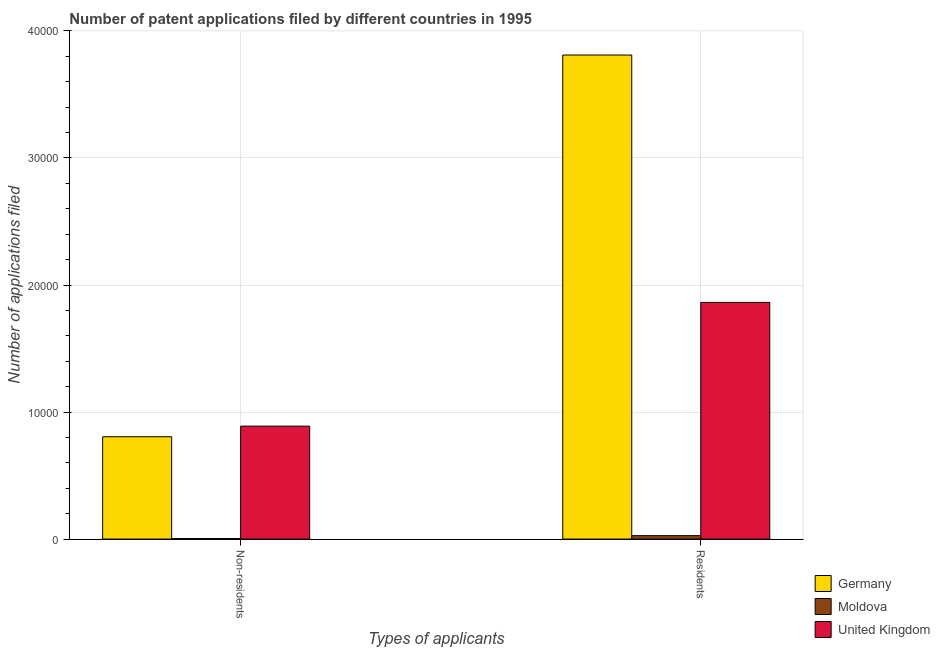How many groups of bars are there?
Provide a short and direct response. 2. Are the number of bars per tick equal to the number of legend labels?
Your answer should be very brief. Yes. Are the number of bars on each tick of the X-axis equal?
Give a very brief answer. Yes. How many bars are there on the 1st tick from the left?
Keep it short and to the point. 3. What is the label of the 2nd group of bars from the left?
Offer a very short reply. Residents. What is the number of patent applications by non residents in United Kingdom?
Make the answer very short. 8891. Across all countries, what is the maximum number of patent applications by residents?
Ensure brevity in your answer.  3.81e+04. Across all countries, what is the minimum number of patent applications by residents?
Keep it short and to the point. 270. In which country was the number of patent applications by residents minimum?
Your answer should be compact. Moldova. What is the total number of patent applications by non residents in the graph?
Make the answer very short. 1.70e+04. What is the difference between the number of patent applications by residents in Germany and that in United Kingdom?
Ensure brevity in your answer.  1.95e+04. What is the difference between the number of patent applications by residents in Germany and the number of patent applications by non residents in United Kingdom?
Give a very brief answer. 2.92e+04. What is the average number of patent applications by non residents per country?
Your response must be concise. 5661.67. What is the difference between the number of patent applications by residents and number of patent applications by non residents in Moldova?
Your answer should be compact. 231. In how many countries, is the number of patent applications by residents greater than 20000 ?
Your response must be concise. 1. What is the ratio of the number of patent applications by non residents in Moldova to that in United Kingdom?
Give a very brief answer. 0. Is the number of patent applications by non residents in Germany less than that in United Kingdom?
Ensure brevity in your answer.  Yes. What does the 3rd bar from the right in Residents represents?
Give a very brief answer. Germany. Are all the bars in the graph horizontal?
Your response must be concise. No. What is the difference between two consecutive major ticks on the Y-axis?
Your answer should be compact. 10000. Are the values on the major ticks of Y-axis written in scientific E-notation?
Provide a short and direct response. No. Does the graph contain any zero values?
Your response must be concise. No. How many legend labels are there?
Your response must be concise. 3. How are the legend labels stacked?
Provide a succinct answer. Vertical. What is the title of the graph?
Your answer should be compact. Number of patent applications filed by different countries in 1995. What is the label or title of the X-axis?
Your answer should be compact. Types of applicants. What is the label or title of the Y-axis?
Your answer should be compact. Number of applications filed. What is the Number of applications filed of Germany in Non-residents?
Offer a very short reply. 8055. What is the Number of applications filed of Moldova in Non-residents?
Your response must be concise. 39. What is the Number of applications filed in United Kingdom in Non-residents?
Your response must be concise. 8891. What is the Number of applications filed of Germany in Residents?
Your response must be concise. 3.81e+04. What is the Number of applications filed in Moldova in Residents?
Offer a very short reply. 270. What is the Number of applications filed of United Kingdom in Residents?
Your response must be concise. 1.86e+04. Across all Types of applicants, what is the maximum Number of applications filed of Germany?
Your response must be concise. 3.81e+04. Across all Types of applicants, what is the maximum Number of applications filed in Moldova?
Your answer should be compact. 270. Across all Types of applicants, what is the maximum Number of applications filed of United Kingdom?
Your answer should be very brief. 1.86e+04. Across all Types of applicants, what is the minimum Number of applications filed in Germany?
Your response must be concise. 8055. Across all Types of applicants, what is the minimum Number of applications filed of United Kingdom?
Keep it short and to the point. 8891. What is the total Number of applications filed of Germany in the graph?
Provide a succinct answer. 4.62e+04. What is the total Number of applications filed of Moldova in the graph?
Give a very brief answer. 309. What is the total Number of applications filed in United Kingdom in the graph?
Your answer should be compact. 2.75e+04. What is the difference between the Number of applications filed in Germany in Non-residents and that in Residents?
Your answer should be very brief. -3.00e+04. What is the difference between the Number of applications filed in Moldova in Non-residents and that in Residents?
Your answer should be compact. -231. What is the difference between the Number of applications filed in United Kingdom in Non-residents and that in Residents?
Your response must be concise. -9739. What is the difference between the Number of applications filed of Germany in Non-residents and the Number of applications filed of Moldova in Residents?
Your answer should be compact. 7785. What is the difference between the Number of applications filed of Germany in Non-residents and the Number of applications filed of United Kingdom in Residents?
Offer a very short reply. -1.06e+04. What is the difference between the Number of applications filed in Moldova in Non-residents and the Number of applications filed in United Kingdom in Residents?
Your answer should be very brief. -1.86e+04. What is the average Number of applications filed of Germany per Types of applicants?
Provide a short and direct response. 2.31e+04. What is the average Number of applications filed of Moldova per Types of applicants?
Your answer should be very brief. 154.5. What is the average Number of applications filed of United Kingdom per Types of applicants?
Give a very brief answer. 1.38e+04. What is the difference between the Number of applications filed of Germany and Number of applications filed of Moldova in Non-residents?
Ensure brevity in your answer.  8016. What is the difference between the Number of applications filed in Germany and Number of applications filed in United Kingdom in Non-residents?
Give a very brief answer. -836. What is the difference between the Number of applications filed of Moldova and Number of applications filed of United Kingdom in Non-residents?
Give a very brief answer. -8852. What is the difference between the Number of applications filed in Germany and Number of applications filed in Moldova in Residents?
Provide a succinct answer. 3.78e+04. What is the difference between the Number of applications filed in Germany and Number of applications filed in United Kingdom in Residents?
Provide a short and direct response. 1.95e+04. What is the difference between the Number of applications filed in Moldova and Number of applications filed in United Kingdom in Residents?
Your answer should be compact. -1.84e+04. What is the ratio of the Number of applications filed of Germany in Non-residents to that in Residents?
Give a very brief answer. 0.21. What is the ratio of the Number of applications filed of Moldova in Non-residents to that in Residents?
Make the answer very short. 0.14. What is the ratio of the Number of applications filed in United Kingdom in Non-residents to that in Residents?
Offer a very short reply. 0.48. What is the difference between the highest and the second highest Number of applications filed in Germany?
Make the answer very short. 3.00e+04. What is the difference between the highest and the second highest Number of applications filed of Moldova?
Offer a very short reply. 231. What is the difference between the highest and the second highest Number of applications filed of United Kingdom?
Provide a short and direct response. 9739. What is the difference between the highest and the lowest Number of applications filed of Germany?
Offer a very short reply. 3.00e+04. What is the difference between the highest and the lowest Number of applications filed in Moldova?
Provide a short and direct response. 231. What is the difference between the highest and the lowest Number of applications filed of United Kingdom?
Offer a very short reply. 9739. 